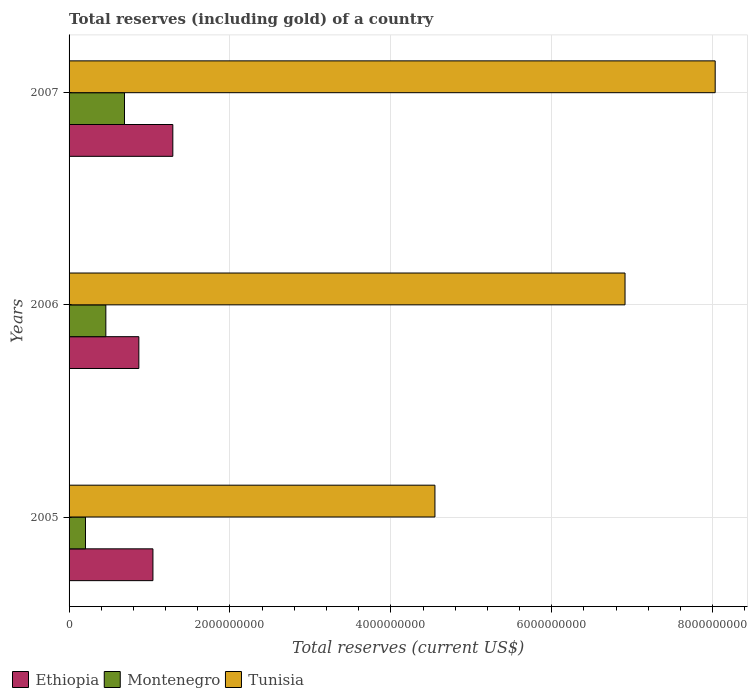How many groups of bars are there?
Offer a terse response. 3. Are the number of bars per tick equal to the number of legend labels?
Make the answer very short. Yes. How many bars are there on the 2nd tick from the top?
Provide a succinct answer. 3. How many bars are there on the 1st tick from the bottom?
Your answer should be very brief. 3. What is the total reserves (including gold) in Montenegro in 2005?
Your answer should be very brief. 2.04e+08. Across all years, what is the maximum total reserves (including gold) in Ethiopia?
Provide a succinct answer. 1.29e+09. Across all years, what is the minimum total reserves (including gold) in Ethiopia?
Offer a very short reply. 8.67e+08. In which year was the total reserves (including gold) in Tunisia maximum?
Offer a very short reply. 2007. What is the total total reserves (including gold) in Tunisia in the graph?
Your answer should be very brief. 1.95e+1. What is the difference between the total reserves (including gold) in Montenegro in 2005 and that in 2007?
Keep it short and to the point. -4.85e+08. What is the difference between the total reserves (including gold) in Montenegro in 2006 and the total reserves (including gold) in Ethiopia in 2005?
Your response must be concise. -5.85e+08. What is the average total reserves (including gold) in Montenegro per year?
Provide a short and direct response. 4.50e+08. In the year 2006, what is the difference between the total reserves (including gold) in Tunisia and total reserves (including gold) in Ethiopia?
Keep it short and to the point. 6.04e+09. In how many years, is the total reserves (including gold) in Montenegro greater than 5600000000 US$?
Your answer should be very brief. 0. What is the ratio of the total reserves (including gold) in Ethiopia in 2005 to that in 2006?
Give a very brief answer. 1.2. Is the total reserves (including gold) in Ethiopia in 2006 less than that in 2007?
Offer a very short reply. Yes. Is the difference between the total reserves (including gold) in Tunisia in 2005 and 2007 greater than the difference between the total reserves (including gold) in Ethiopia in 2005 and 2007?
Provide a succinct answer. No. What is the difference between the highest and the second highest total reserves (including gold) in Montenegro?
Ensure brevity in your answer.  2.32e+08. What is the difference between the highest and the lowest total reserves (including gold) in Tunisia?
Provide a short and direct response. 3.48e+09. Is the sum of the total reserves (including gold) in Ethiopia in 2005 and 2006 greater than the maximum total reserves (including gold) in Tunisia across all years?
Keep it short and to the point. No. What does the 2nd bar from the top in 2006 represents?
Your answer should be compact. Montenegro. What does the 1st bar from the bottom in 2005 represents?
Offer a terse response. Ethiopia. How many bars are there?
Ensure brevity in your answer.  9. Are all the bars in the graph horizontal?
Offer a very short reply. Yes. How many years are there in the graph?
Provide a succinct answer. 3. What is the difference between two consecutive major ticks on the X-axis?
Give a very brief answer. 2.00e+09. Does the graph contain any zero values?
Give a very brief answer. No. Does the graph contain grids?
Make the answer very short. Yes. How many legend labels are there?
Ensure brevity in your answer.  3. How are the legend labels stacked?
Your answer should be very brief. Horizontal. What is the title of the graph?
Offer a terse response. Total reserves (including gold) of a country. What is the label or title of the X-axis?
Keep it short and to the point. Total reserves (current US$). What is the label or title of the Y-axis?
Offer a very short reply. Years. What is the Total reserves (current US$) in Ethiopia in 2005?
Your answer should be compact. 1.04e+09. What is the Total reserves (current US$) of Montenegro in 2005?
Ensure brevity in your answer.  2.04e+08. What is the Total reserves (current US$) in Tunisia in 2005?
Provide a short and direct response. 4.55e+09. What is the Total reserves (current US$) in Ethiopia in 2006?
Your response must be concise. 8.67e+08. What is the Total reserves (current US$) of Montenegro in 2006?
Provide a short and direct response. 4.57e+08. What is the Total reserves (current US$) in Tunisia in 2006?
Provide a short and direct response. 6.91e+09. What is the Total reserves (current US$) of Ethiopia in 2007?
Offer a very short reply. 1.29e+09. What is the Total reserves (current US$) in Montenegro in 2007?
Your answer should be compact. 6.89e+08. What is the Total reserves (current US$) in Tunisia in 2007?
Provide a succinct answer. 8.03e+09. Across all years, what is the maximum Total reserves (current US$) of Ethiopia?
Your answer should be very brief. 1.29e+09. Across all years, what is the maximum Total reserves (current US$) of Montenegro?
Your response must be concise. 6.89e+08. Across all years, what is the maximum Total reserves (current US$) of Tunisia?
Ensure brevity in your answer.  8.03e+09. Across all years, what is the minimum Total reserves (current US$) in Ethiopia?
Offer a terse response. 8.67e+08. Across all years, what is the minimum Total reserves (current US$) in Montenegro?
Your response must be concise. 2.04e+08. Across all years, what is the minimum Total reserves (current US$) in Tunisia?
Offer a terse response. 4.55e+09. What is the total Total reserves (current US$) in Ethiopia in the graph?
Make the answer very short. 3.20e+09. What is the total Total reserves (current US$) of Montenegro in the graph?
Your answer should be compact. 1.35e+09. What is the total Total reserves (current US$) of Tunisia in the graph?
Make the answer very short. 1.95e+1. What is the difference between the Total reserves (current US$) of Ethiopia in 2005 and that in 2006?
Offer a very short reply. 1.75e+08. What is the difference between the Total reserves (current US$) of Montenegro in 2005 and that in 2006?
Provide a short and direct response. -2.53e+08. What is the difference between the Total reserves (current US$) in Tunisia in 2005 and that in 2006?
Offer a terse response. -2.36e+09. What is the difference between the Total reserves (current US$) in Ethiopia in 2005 and that in 2007?
Keep it short and to the point. -2.47e+08. What is the difference between the Total reserves (current US$) in Montenegro in 2005 and that in 2007?
Make the answer very short. -4.85e+08. What is the difference between the Total reserves (current US$) of Tunisia in 2005 and that in 2007?
Make the answer very short. -3.48e+09. What is the difference between the Total reserves (current US$) in Ethiopia in 2006 and that in 2007?
Offer a terse response. -4.22e+08. What is the difference between the Total reserves (current US$) in Montenegro in 2006 and that in 2007?
Make the answer very short. -2.32e+08. What is the difference between the Total reserves (current US$) of Tunisia in 2006 and that in 2007?
Your answer should be compact. -1.12e+09. What is the difference between the Total reserves (current US$) of Ethiopia in 2005 and the Total reserves (current US$) of Montenegro in 2006?
Your answer should be very brief. 5.85e+08. What is the difference between the Total reserves (current US$) in Ethiopia in 2005 and the Total reserves (current US$) in Tunisia in 2006?
Provide a short and direct response. -5.87e+09. What is the difference between the Total reserves (current US$) of Montenegro in 2005 and the Total reserves (current US$) of Tunisia in 2006?
Your response must be concise. -6.71e+09. What is the difference between the Total reserves (current US$) of Ethiopia in 2005 and the Total reserves (current US$) of Montenegro in 2007?
Ensure brevity in your answer.  3.54e+08. What is the difference between the Total reserves (current US$) of Ethiopia in 2005 and the Total reserves (current US$) of Tunisia in 2007?
Your answer should be compact. -6.99e+09. What is the difference between the Total reserves (current US$) in Montenegro in 2005 and the Total reserves (current US$) in Tunisia in 2007?
Offer a terse response. -7.83e+09. What is the difference between the Total reserves (current US$) in Ethiopia in 2006 and the Total reserves (current US$) in Montenegro in 2007?
Your answer should be very brief. 1.79e+08. What is the difference between the Total reserves (current US$) in Ethiopia in 2006 and the Total reserves (current US$) in Tunisia in 2007?
Keep it short and to the point. -7.16e+09. What is the difference between the Total reserves (current US$) in Montenegro in 2006 and the Total reserves (current US$) in Tunisia in 2007?
Keep it short and to the point. -7.58e+09. What is the average Total reserves (current US$) in Ethiopia per year?
Provide a succinct answer. 1.07e+09. What is the average Total reserves (current US$) in Montenegro per year?
Provide a short and direct response. 4.50e+08. What is the average Total reserves (current US$) in Tunisia per year?
Keep it short and to the point. 6.50e+09. In the year 2005, what is the difference between the Total reserves (current US$) of Ethiopia and Total reserves (current US$) of Montenegro?
Provide a succinct answer. 8.39e+08. In the year 2005, what is the difference between the Total reserves (current US$) of Ethiopia and Total reserves (current US$) of Tunisia?
Give a very brief answer. -3.51e+09. In the year 2005, what is the difference between the Total reserves (current US$) in Montenegro and Total reserves (current US$) in Tunisia?
Offer a very short reply. -4.34e+09. In the year 2006, what is the difference between the Total reserves (current US$) in Ethiopia and Total reserves (current US$) in Montenegro?
Ensure brevity in your answer.  4.10e+08. In the year 2006, what is the difference between the Total reserves (current US$) of Ethiopia and Total reserves (current US$) of Tunisia?
Your answer should be very brief. -6.04e+09. In the year 2006, what is the difference between the Total reserves (current US$) in Montenegro and Total reserves (current US$) in Tunisia?
Offer a very short reply. -6.45e+09. In the year 2007, what is the difference between the Total reserves (current US$) in Ethiopia and Total reserves (current US$) in Montenegro?
Ensure brevity in your answer.  6.01e+08. In the year 2007, what is the difference between the Total reserves (current US$) in Ethiopia and Total reserves (current US$) in Tunisia?
Your answer should be compact. -6.74e+09. In the year 2007, what is the difference between the Total reserves (current US$) in Montenegro and Total reserves (current US$) in Tunisia?
Keep it short and to the point. -7.34e+09. What is the ratio of the Total reserves (current US$) in Ethiopia in 2005 to that in 2006?
Give a very brief answer. 1.2. What is the ratio of the Total reserves (current US$) in Montenegro in 2005 to that in 2006?
Your response must be concise. 0.45. What is the ratio of the Total reserves (current US$) of Tunisia in 2005 to that in 2006?
Keep it short and to the point. 0.66. What is the ratio of the Total reserves (current US$) in Ethiopia in 2005 to that in 2007?
Ensure brevity in your answer.  0.81. What is the ratio of the Total reserves (current US$) in Montenegro in 2005 to that in 2007?
Give a very brief answer. 0.3. What is the ratio of the Total reserves (current US$) in Tunisia in 2005 to that in 2007?
Your response must be concise. 0.57. What is the ratio of the Total reserves (current US$) of Ethiopia in 2006 to that in 2007?
Keep it short and to the point. 0.67. What is the ratio of the Total reserves (current US$) in Montenegro in 2006 to that in 2007?
Keep it short and to the point. 0.66. What is the ratio of the Total reserves (current US$) in Tunisia in 2006 to that in 2007?
Make the answer very short. 0.86. What is the difference between the highest and the second highest Total reserves (current US$) of Ethiopia?
Your response must be concise. 2.47e+08. What is the difference between the highest and the second highest Total reserves (current US$) of Montenegro?
Give a very brief answer. 2.32e+08. What is the difference between the highest and the second highest Total reserves (current US$) in Tunisia?
Keep it short and to the point. 1.12e+09. What is the difference between the highest and the lowest Total reserves (current US$) of Ethiopia?
Your response must be concise. 4.22e+08. What is the difference between the highest and the lowest Total reserves (current US$) of Montenegro?
Offer a very short reply. 4.85e+08. What is the difference between the highest and the lowest Total reserves (current US$) of Tunisia?
Ensure brevity in your answer.  3.48e+09. 